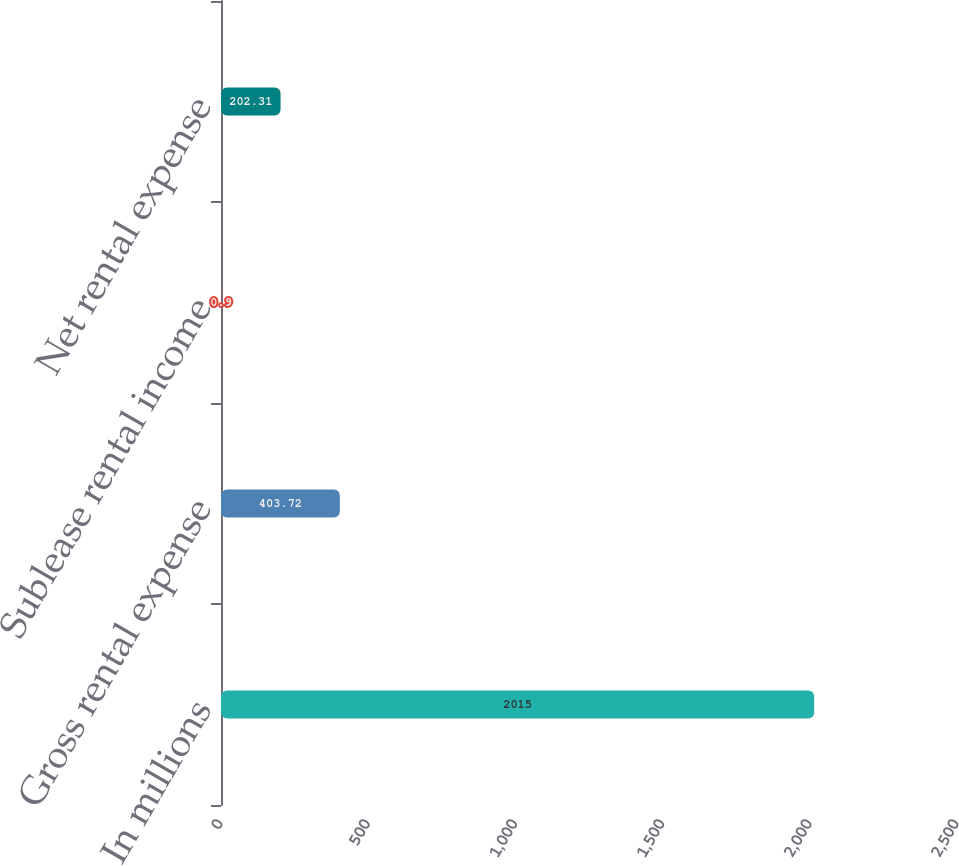Convert chart to OTSL. <chart><loc_0><loc_0><loc_500><loc_500><bar_chart><fcel>In millions<fcel>Gross rental expense<fcel>Sublease rental income<fcel>Net rental expense<nl><fcel>2015<fcel>403.72<fcel>0.9<fcel>202.31<nl></chart> 